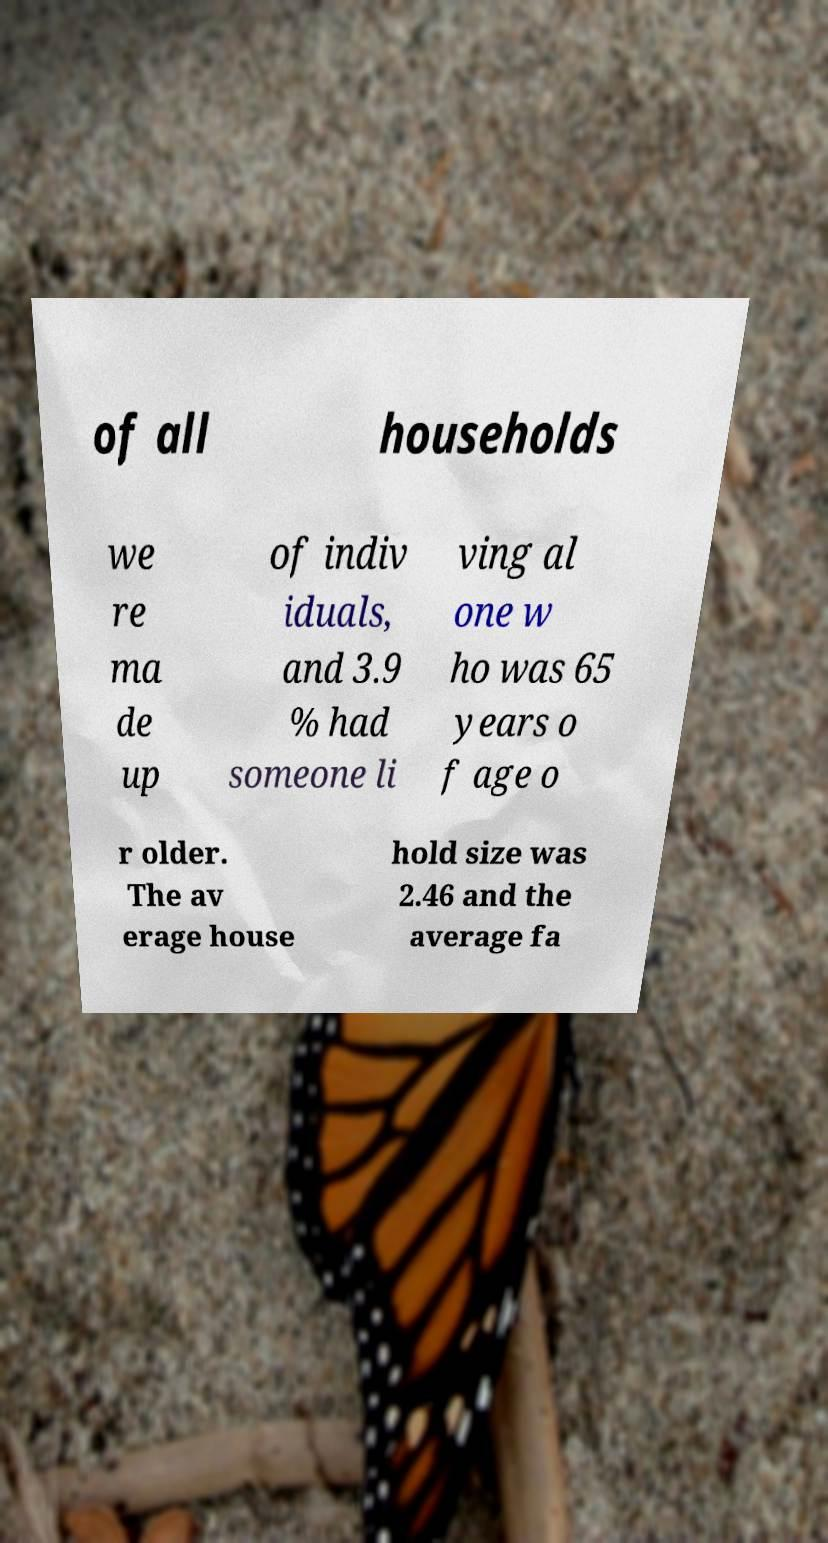Could you assist in decoding the text presented in this image and type it out clearly? of all households we re ma de up of indiv iduals, and 3.9 % had someone li ving al one w ho was 65 years o f age o r older. The av erage house hold size was 2.46 and the average fa 